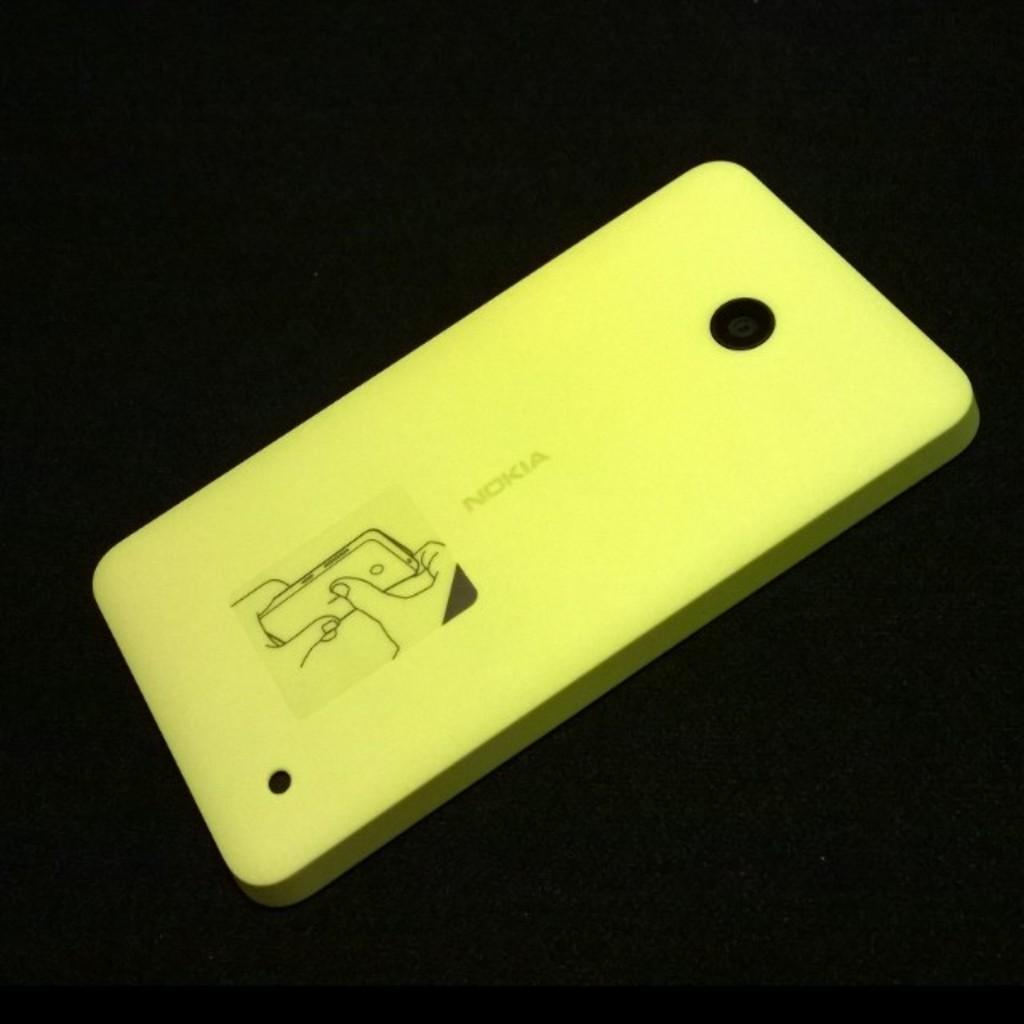Can you describe this image briefly? In this image, this looks like a mobile case cover, which is yellow in color. The background looks dark. 